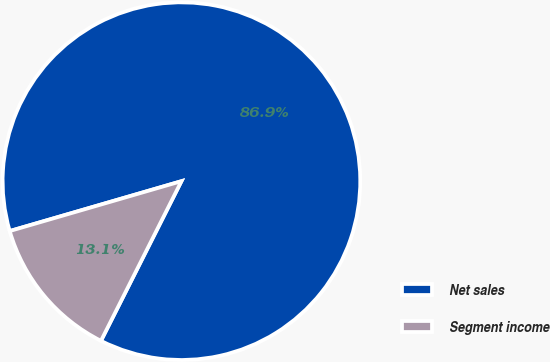Convert chart. <chart><loc_0><loc_0><loc_500><loc_500><pie_chart><fcel>Net sales<fcel>Segment income<nl><fcel>86.93%<fcel>13.07%<nl></chart> 